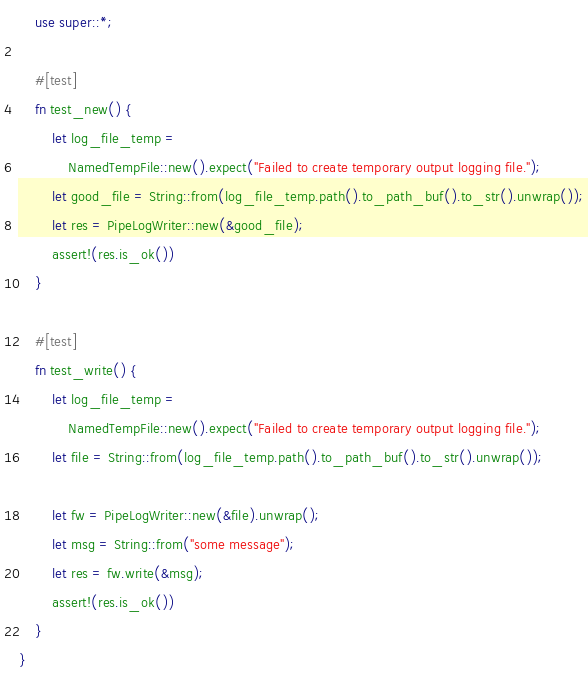Convert code to text. <code><loc_0><loc_0><loc_500><loc_500><_Rust_>    use super::*;

    #[test]
    fn test_new() {
        let log_file_temp =
            NamedTempFile::new().expect("Failed to create temporary output logging file.");
        let good_file = String::from(log_file_temp.path().to_path_buf().to_str().unwrap());
        let res = PipeLogWriter::new(&good_file);
        assert!(res.is_ok())
    }

    #[test]
    fn test_write() {
        let log_file_temp =
            NamedTempFile::new().expect("Failed to create temporary output logging file.");
        let file = String::from(log_file_temp.path().to_path_buf().to_str().unwrap());

        let fw = PipeLogWriter::new(&file).unwrap();
        let msg = String::from("some message");
        let res = fw.write(&msg);
        assert!(res.is_ok())
    }
}
</code> 